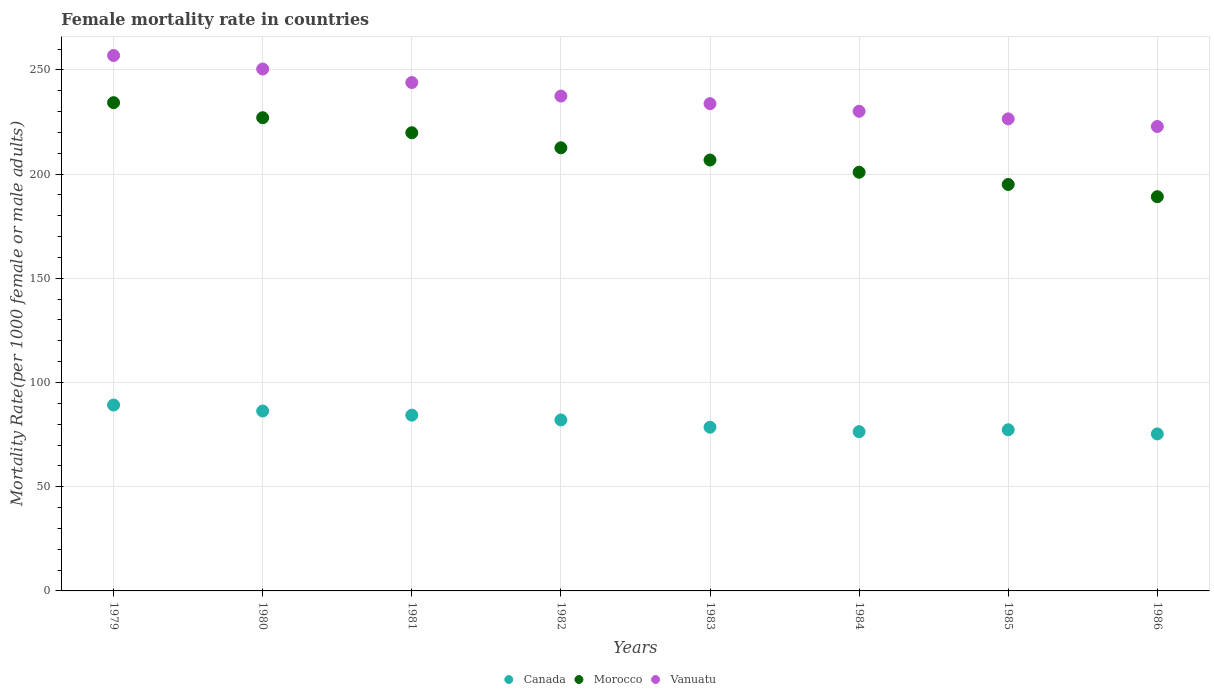How many different coloured dotlines are there?
Give a very brief answer. 3. What is the female mortality rate in Morocco in 1982?
Offer a very short reply. 212.62. Across all years, what is the maximum female mortality rate in Morocco?
Offer a terse response. 234.28. Across all years, what is the minimum female mortality rate in Canada?
Offer a terse response. 75.33. In which year was the female mortality rate in Morocco maximum?
Keep it short and to the point. 1979. In which year was the female mortality rate in Vanuatu minimum?
Make the answer very short. 1986. What is the total female mortality rate in Canada in the graph?
Ensure brevity in your answer.  649.49. What is the difference between the female mortality rate in Canada in 1981 and that in 1986?
Offer a terse response. 9. What is the difference between the female mortality rate in Vanuatu in 1981 and the female mortality rate in Morocco in 1980?
Offer a very short reply. 16.88. What is the average female mortality rate in Morocco per year?
Offer a very short reply. 210.7. In the year 1984, what is the difference between the female mortality rate in Morocco and female mortality rate in Vanuatu?
Ensure brevity in your answer.  -29.26. What is the ratio of the female mortality rate in Morocco in 1979 to that in 1982?
Make the answer very short. 1.1. Is the difference between the female mortality rate in Morocco in 1982 and 1984 greater than the difference between the female mortality rate in Vanuatu in 1982 and 1984?
Provide a succinct answer. Yes. What is the difference between the highest and the second highest female mortality rate in Vanuatu?
Offer a very short reply. 6.49. What is the difference between the highest and the lowest female mortality rate in Vanuatu?
Offer a terse response. 34.06. Is the sum of the female mortality rate in Morocco in 1982 and 1984 greater than the maximum female mortality rate in Canada across all years?
Your response must be concise. Yes. How many dotlines are there?
Your answer should be very brief. 3. How many years are there in the graph?
Your answer should be compact. 8. What is the difference between two consecutive major ticks on the Y-axis?
Your response must be concise. 50. Are the values on the major ticks of Y-axis written in scientific E-notation?
Give a very brief answer. No. Does the graph contain any zero values?
Your response must be concise. No. How are the legend labels stacked?
Your response must be concise. Horizontal. What is the title of the graph?
Ensure brevity in your answer.  Female mortality rate in countries. What is the label or title of the X-axis?
Give a very brief answer. Years. What is the label or title of the Y-axis?
Provide a succinct answer. Mortality Rate(per 1000 female or male adults). What is the Mortality Rate(per 1000 female or male adults) of Canada in 1979?
Make the answer very short. 89.19. What is the Mortality Rate(per 1000 female or male adults) in Morocco in 1979?
Make the answer very short. 234.28. What is the Mortality Rate(per 1000 female or male adults) of Vanuatu in 1979?
Your answer should be compact. 256.9. What is the Mortality Rate(per 1000 female or male adults) of Canada in 1980?
Your answer should be compact. 86.32. What is the Mortality Rate(per 1000 female or male adults) of Morocco in 1980?
Your response must be concise. 227.06. What is the Mortality Rate(per 1000 female or male adults) in Vanuatu in 1980?
Give a very brief answer. 250.42. What is the Mortality Rate(per 1000 female or male adults) in Canada in 1981?
Give a very brief answer. 84.34. What is the Mortality Rate(per 1000 female or male adults) in Morocco in 1981?
Provide a short and direct response. 219.84. What is the Mortality Rate(per 1000 female or male adults) of Vanuatu in 1981?
Make the answer very short. 243.93. What is the Mortality Rate(per 1000 female or male adults) of Canada in 1982?
Your answer should be very brief. 82.03. What is the Mortality Rate(per 1000 female or male adults) in Morocco in 1982?
Offer a very short reply. 212.62. What is the Mortality Rate(per 1000 female or male adults) of Vanuatu in 1982?
Your answer should be very brief. 237.45. What is the Mortality Rate(per 1000 female or male adults) in Canada in 1983?
Keep it short and to the point. 78.54. What is the Mortality Rate(per 1000 female or male adults) of Morocco in 1983?
Provide a short and direct response. 206.75. What is the Mortality Rate(per 1000 female or male adults) in Vanuatu in 1983?
Your answer should be very brief. 233.79. What is the Mortality Rate(per 1000 female or male adults) of Canada in 1984?
Offer a terse response. 76.41. What is the Mortality Rate(per 1000 female or male adults) of Morocco in 1984?
Your answer should be compact. 200.89. What is the Mortality Rate(per 1000 female or male adults) in Vanuatu in 1984?
Offer a terse response. 230.14. What is the Mortality Rate(per 1000 female or male adults) of Canada in 1985?
Make the answer very short. 77.33. What is the Mortality Rate(per 1000 female or male adults) of Morocco in 1985?
Your response must be concise. 195.02. What is the Mortality Rate(per 1000 female or male adults) of Vanuatu in 1985?
Provide a succinct answer. 226.49. What is the Mortality Rate(per 1000 female or male adults) in Canada in 1986?
Provide a succinct answer. 75.33. What is the Mortality Rate(per 1000 female or male adults) in Morocco in 1986?
Offer a terse response. 189.16. What is the Mortality Rate(per 1000 female or male adults) of Vanuatu in 1986?
Offer a terse response. 222.84. Across all years, what is the maximum Mortality Rate(per 1000 female or male adults) of Canada?
Provide a short and direct response. 89.19. Across all years, what is the maximum Mortality Rate(per 1000 female or male adults) in Morocco?
Your response must be concise. 234.28. Across all years, what is the maximum Mortality Rate(per 1000 female or male adults) in Vanuatu?
Your answer should be compact. 256.9. Across all years, what is the minimum Mortality Rate(per 1000 female or male adults) of Canada?
Make the answer very short. 75.33. Across all years, what is the minimum Mortality Rate(per 1000 female or male adults) in Morocco?
Provide a short and direct response. 189.16. Across all years, what is the minimum Mortality Rate(per 1000 female or male adults) in Vanuatu?
Keep it short and to the point. 222.84. What is the total Mortality Rate(per 1000 female or male adults) in Canada in the graph?
Make the answer very short. 649.49. What is the total Mortality Rate(per 1000 female or male adults) of Morocco in the graph?
Offer a very short reply. 1685.6. What is the total Mortality Rate(per 1000 female or male adults) of Vanuatu in the graph?
Your answer should be very brief. 1901.97. What is the difference between the Mortality Rate(per 1000 female or male adults) in Canada in 1979 and that in 1980?
Your answer should be very brief. 2.88. What is the difference between the Mortality Rate(per 1000 female or male adults) in Morocco in 1979 and that in 1980?
Your answer should be very brief. 7.22. What is the difference between the Mortality Rate(per 1000 female or male adults) in Vanuatu in 1979 and that in 1980?
Your response must be concise. 6.49. What is the difference between the Mortality Rate(per 1000 female or male adults) in Canada in 1979 and that in 1981?
Make the answer very short. 4.86. What is the difference between the Mortality Rate(per 1000 female or male adults) of Morocco in 1979 and that in 1981?
Your answer should be compact. 14.44. What is the difference between the Mortality Rate(per 1000 female or male adults) in Vanuatu in 1979 and that in 1981?
Ensure brevity in your answer.  12.97. What is the difference between the Mortality Rate(per 1000 female or male adults) of Canada in 1979 and that in 1982?
Offer a terse response. 7.16. What is the difference between the Mortality Rate(per 1000 female or male adults) in Morocco in 1979 and that in 1982?
Offer a terse response. 21.66. What is the difference between the Mortality Rate(per 1000 female or male adults) in Vanuatu in 1979 and that in 1982?
Provide a succinct answer. 19.46. What is the difference between the Mortality Rate(per 1000 female or male adults) in Canada in 1979 and that in 1983?
Your response must be concise. 10.65. What is the difference between the Mortality Rate(per 1000 female or male adults) of Morocco in 1979 and that in 1983?
Your answer should be very brief. 27.52. What is the difference between the Mortality Rate(per 1000 female or male adults) in Vanuatu in 1979 and that in 1983?
Ensure brevity in your answer.  23.11. What is the difference between the Mortality Rate(per 1000 female or male adults) in Canada in 1979 and that in 1984?
Your answer should be very brief. 12.78. What is the difference between the Mortality Rate(per 1000 female or male adults) in Morocco in 1979 and that in 1984?
Your response must be concise. 33.39. What is the difference between the Mortality Rate(per 1000 female or male adults) of Vanuatu in 1979 and that in 1984?
Offer a terse response. 26.76. What is the difference between the Mortality Rate(per 1000 female or male adults) in Canada in 1979 and that in 1985?
Offer a very short reply. 11.87. What is the difference between the Mortality Rate(per 1000 female or male adults) in Morocco in 1979 and that in 1985?
Provide a short and direct response. 39.26. What is the difference between the Mortality Rate(per 1000 female or male adults) of Vanuatu in 1979 and that in 1985?
Your answer should be very brief. 30.41. What is the difference between the Mortality Rate(per 1000 female or male adults) of Canada in 1979 and that in 1986?
Provide a succinct answer. 13.86. What is the difference between the Mortality Rate(per 1000 female or male adults) of Morocco in 1979 and that in 1986?
Provide a succinct answer. 45.12. What is the difference between the Mortality Rate(per 1000 female or male adults) in Vanuatu in 1979 and that in 1986?
Your response must be concise. 34.06. What is the difference between the Mortality Rate(per 1000 female or male adults) in Canada in 1980 and that in 1981?
Ensure brevity in your answer.  1.98. What is the difference between the Mortality Rate(per 1000 female or male adults) of Morocco in 1980 and that in 1981?
Provide a succinct answer. 7.22. What is the difference between the Mortality Rate(per 1000 female or male adults) in Vanuatu in 1980 and that in 1981?
Make the answer very short. 6.49. What is the difference between the Mortality Rate(per 1000 female or male adults) in Canada in 1980 and that in 1982?
Your answer should be very brief. 4.28. What is the difference between the Mortality Rate(per 1000 female or male adults) in Morocco in 1980 and that in 1982?
Offer a terse response. 14.44. What is the difference between the Mortality Rate(per 1000 female or male adults) of Vanuatu in 1980 and that in 1982?
Offer a terse response. 12.97. What is the difference between the Mortality Rate(per 1000 female or male adults) in Canada in 1980 and that in 1983?
Give a very brief answer. 7.78. What is the difference between the Mortality Rate(per 1000 female or male adults) of Morocco in 1980 and that in 1983?
Your answer should be very brief. 20.3. What is the difference between the Mortality Rate(per 1000 female or male adults) of Vanuatu in 1980 and that in 1983?
Make the answer very short. 16.62. What is the difference between the Mortality Rate(per 1000 female or male adults) in Canada in 1980 and that in 1984?
Give a very brief answer. 9.9. What is the difference between the Mortality Rate(per 1000 female or male adults) of Morocco in 1980 and that in 1984?
Ensure brevity in your answer.  26.17. What is the difference between the Mortality Rate(per 1000 female or male adults) of Vanuatu in 1980 and that in 1984?
Make the answer very short. 20.27. What is the difference between the Mortality Rate(per 1000 female or male adults) of Canada in 1980 and that in 1985?
Ensure brevity in your answer.  8.99. What is the difference between the Mortality Rate(per 1000 female or male adults) of Morocco in 1980 and that in 1985?
Your answer should be compact. 32.03. What is the difference between the Mortality Rate(per 1000 female or male adults) in Vanuatu in 1980 and that in 1985?
Keep it short and to the point. 23.93. What is the difference between the Mortality Rate(per 1000 female or male adults) of Canada in 1980 and that in 1986?
Your response must be concise. 10.98. What is the difference between the Mortality Rate(per 1000 female or male adults) of Morocco in 1980 and that in 1986?
Offer a very short reply. 37.9. What is the difference between the Mortality Rate(per 1000 female or male adults) of Vanuatu in 1980 and that in 1986?
Provide a succinct answer. 27.58. What is the difference between the Mortality Rate(per 1000 female or male adults) in Canada in 1981 and that in 1982?
Provide a succinct answer. 2.31. What is the difference between the Mortality Rate(per 1000 female or male adults) of Morocco in 1981 and that in 1982?
Make the answer very short. 7.22. What is the difference between the Mortality Rate(per 1000 female or male adults) in Vanuatu in 1981 and that in 1982?
Make the answer very short. 6.49. What is the difference between the Mortality Rate(per 1000 female or male adults) of Canada in 1981 and that in 1983?
Provide a succinct answer. 5.8. What is the difference between the Mortality Rate(per 1000 female or male adults) of Morocco in 1981 and that in 1983?
Your answer should be very brief. 13.09. What is the difference between the Mortality Rate(per 1000 female or male adults) of Vanuatu in 1981 and that in 1983?
Provide a succinct answer. 10.14. What is the difference between the Mortality Rate(per 1000 female or male adults) of Canada in 1981 and that in 1984?
Offer a very short reply. 7.93. What is the difference between the Mortality Rate(per 1000 female or male adults) of Morocco in 1981 and that in 1984?
Your response must be concise. 18.95. What is the difference between the Mortality Rate(per 1000 female or male adults) in Vanuatu in 1981 and that in 1984?
Offer a terse response. 13.79. What is the difference between the Mortality Rate(per 1000 female or male adults) of Canada in 1981 and that in 1985?
Make the answer very short. 7.01. What is the difference between the Mortality Rate(per 1000 female or male adults) in Morocco in 1981 and that in 1985?
Keep it short and to the point. 24.82. What is the difference between the Mortality Rate(per 1000 female or male adults) in Vanuatu in 1981 and that in 1985?
Offer a terse response. 17.44. What is the difference between the Mortality Rate(per 1000 female or male adults) of Canada in 1981 and that in 1986?
Keep it short and to the point. 9. What is the difference between the Mortality Rate(per 1000 female or male adults) in Morocco in 1981 and that in 1986?
Your answer should be very brief. 30.68. What is the difference between the Mortality Rate(per 1000 female or male adults) of Vanuatu in 1981 and that in 1986?
Keep it short and to the point. 21.09. What is the difference between the Mortality Rate(per 1000 female or male adults) of Canada in 1982 and that in 1983?
Provide a succinct answer. 3.49. What is the difference between the Mortality Rate(per 1000 female or male adults) in Morocco in 1982 and that in 1983?
Provide a short and direct response. 5.87. What is the difference between the Mortality Rate(per 1000 female or male adults) in Vanuatu in 1982 and that in 1983?
Offer a very short reply. 3.65. What is the difference between the Mortality Rate(per 1000 female or male adults) of Canada in 1982 and that in 1984?
Offer a very short reply. 5.62. What is the difference between the Mortality Rate(per 1000 female or male adults) in Morocco in 1982 and that in 1984?
Offer a very short reply. 11.73. What is the difference between the Mortality Rate(per 1000 female or male adults) in Vanuatu in 1982 and that in 1984?
Keep it short and to the point. 7.3. What is the difference between the Mortality Rate(per 1000 female or male adults) of Canada in 1982 and that in 1985?
Make the answer very short. 4.71. What is the difference between the Mortality Rate(per 1000 female or male adults) in Morocco in 1982 and that in 1985?
Offer a terse response. 17.6. What is the difference between the Mortality Rate(per 1000 female or male adults) of Vanuatu in 1982 and that in 1985?
Your response must be concise. 10.96. What is the difference between the Mortality Rate(per 1000 female or male adults) of Canada in 1982 and that in 1986?
Your response must be concise. 6.7. What is the difference between the Mortality Rate(per 1000 female or male adults) in Morocco in 1982 and that in 1986?
Make the answer very short. 23.46. What is the difference between the Mortality Rate(per 1000 female or male adults) of Vanuatu in 1982 and that in 1986?
Provide a succinct answer. 14.61. What is the difference between the Mortality Rate(per 1000 female or male adults) of Canada in 1983 and that in 1984?
Provide a succinct answer. 2.13. What is the difference between the Mortality Rate(per 1000 female or male adults) in Morocco in 1983 and that in 1984?
Provide a short and direct response. 5.87. What is the difference between the Mortality Rate(per 1000 female or male adults) of Vanuatu in 1983 and that in 1984?
Your answer should be very brief. 3.65. What is the difference between the Mortality Rate(per 1000 female or male adults) in Canada in 1983 and that in 1985?
Give a very brief answer. 1.21. What is the difference between the Mortality Rate(per 1000 female or male adults) in Morocco in 1983 and that in 1985?
Your answer should be very brief. 11.73. What is the difference between the Mortality Rate(per 1000 female or male adults) in Vanuatu in 1983 and that in 1985?
Your answer should be compact. 7.3. What is the difference between the Mortality Rate(per 1000 female or male adults) in Canada in 1983 and that in 1986?
Offer a very short reply. 3.21. What is the difference between the Mortality Rate(per 1000 female or male adults) of Morocco in 1983 and that in 1986?
Make the answer very short. 17.6. What is the difference between the Mortality Rate(per 1000 female or male adults) of Vanuatu in 1983 and that in 1986?
Your answer should be very brief. 10.96. What is the difference between the Mortality Rate(per 1000 female or male adults) in Canada in 1984 and that in 1985?
Make the answer very short. -0.92. What is the difference between the Mortality Rate(per 1000 female or male adults) in Morocco in 1984 and that in 1985?
Offer a terse response. 5.87. What is the difference between the Mortality Rate(per 1000 female or male adults) in Vanuatu in 1984 and that in 1985?
Your answer should be very brief. 3.65. What is the difference between the Mortality Rate(per 1000 female or male adults) of Canada in 1984 and that in 1986?
Make the answer very short. 1.08. What is the difference between the Mortality Rate(per 1000 female or male adults) of Morocco in 1984 and that in 1986?
Keep it short and to the point. 11.73. What is the difference between the Mortality Rate(per 1000 female or male adults) in Vanuatu in 1984 and that in 1986?
Keep it short and to the point. 7.3. What is the difference between the Mortality Rate(per 1000 female or male adults) of Canada in 1985 and that in 1986?
Provide a short and direct response. 1.99. What is the difference between the Mortality Rate(per 1000 female or male adults) in Morocco in 1985 and that in 1986?
Your answer should be very brief. 5.87. What is the difference between the Mortality Rate(per 1000 female or male adults) in Vanuatu in 1985 and that in 1986?
Your answer should be compact. 3.65. What is the difference between the Mortality Rate(per 1000 female or male adults) in Canada in 1979 and the Mortality Rate(per 1000 female or male adults) in Morocco in 1980?
Your response must be concise. -137.86. What is the difference between the Mortality Rate(per 1000 female or male adults) in Canada in 1979 and the Mortality Rate(per 1000 female or male adults) in Vanuatu in 1980?
Give a very brief answer. -161.22. What is the difference between the Mortality Rate(per 1000 female or male adults) in Morocco in 1979 and the Mortality Rate(per 1000 female or male adults) in Vanuatu in 1980?
Provide a succinct answer. -16.14. What is the difference between the Mortality Rate(per 1000 female or male adults) in Canada in 1979 and the Mortality Rate(per 1000 female or male adults) in Morocco in 1981?
Your response must be concise. -130.64. What is the difference between the Mortality Rate(per 1000 female or male adults) in Canada in 1979 and the Mortality Rate(per 1000 female or male adults) in Vanuatu in 1981?
Keep it short and to the point. -154.74. What is the difference between the Mortality Rate(per 1000 female or male adults) of Morocco in 1979 and the Mortality Rate(per 1000 female or male adults) of Vanuatu in 1981?
Offer a terse response. -9.66. What is the difference between the Mortality Rate(per 1000 female or male adults) in Canada in 1979 and the Mortality Rate(per 1000 female or male adults) in Morocco in 1982?
Keep it short and to the point. -123.42. What is the difference between the Mortality Rate(per 1000 female or male adults) in Canada in 1979 and the Mortality Rate(per 1000 female or male adults) in Vanuatu in 1982?
Offer a terse response. -148.25. What is the difference between the Mortality Rate(per 1000 female or male adults) of Morocco in 1979 and the Mortality Rate(per 1000 female or male adults) of Vanuatu in 1982?
Your response must be concise. -3.17. What is the difference between the Mortality Rate(per 1000 female or male adults) of Canada in 1979 and the Mortality Rate(per 1000 female or male adults) of Morocco in 1983?
Offer a very short reply. -117.56. What is the difference between the Mortality Rate(per 1000 female or male adults) of Canada in 1979 and the Mortality Rate(per 1000 female or male adults) of Vanuatu in 1983?
Make the answer very short. -144.6. What is the difference between the Mortality Rate(per 1000 female or male adults) in Morocco in 1979 and the Mortality Rate(per 1000 female or male adults) in Vanuatu in 1983?
Give a very brief answer. 0.48. What is the difference between the Mortality Rate(per 1000 female or male adults) in Canada in 1979 and the Mortality Rate(per 1000 female or male adults) in Morocco in 1984?
Make the answer very short. -111.69. What is the difference between the Mortality Rate(per 1000 female or male adults) in Canada in 1979 and the Mortality Rate(per 1000 female or male adults) in Vanuatu in 1984?
Ensure brevity in your answer.  -140.95. What is the difference between the Mortality Rate(per 1000 female or male adults) of Morocco in 1979 and the Mortality Rate(per 1000 female or male adults) of Vanuatu in 1984?
Make the answer very short. 4.13. What is the difference between the Mortality Rate(per 1000 female or male adults) in Canada in 1979 and the Mortality Rate(per 1000 female or male adults) in Morocco in 1985?
Keep it short and to the point. -105.83. What is the difference between the Mortality Rate(per 1000 female or male adults) of Canada in 1979 and the Mortality Rate(per 1000 female or male adults) of Vanuatu in 1985?
Keep it short and to the point. -137.3. What is the difference between the Mortality Rate(per 1000 female or male adults) in Morocco in 1979 and the Mortality Rate(per 1000 female or male adults) in Vanuatu in 1985?
Provide a short and direct response. 7.78. What is the difference between the Mortality Rate(per 1000 female or male adults) in Canada in 1979 and the Mortality Rate(per 1000 female or male adults) in Morocco in 1986?
Give a very brief answer. -99.96. What is the difference between the Mortality Rate(per 1000 female or male adults) of Canada in 1979 and the Mortality Rate(per 1000 female or male adults) of Vanuatu in 1986?
Ensure brevity in your answer.  -133.65. What is the difference between the Mortality Rate(per 1000 female or male adults) in Morocco in 1979 and the Mortality Rate(per 1000 female or male adults) in Vanuatu in 1986?
Make the answer very short. 11.44. What is the difference between the Mortality Rate(per 1000 female or male adults) of Canada in 1980 and the Mortality Rate(per 1000 female or male adults) of Morocco in 1981?
Your answer should be very brief. -133.52. What is the difference between the Mortality Rate(per 1000 female or male adults) in Canada in 1980 and the Mortality Rate(per 1000 female or male adults) in Vanuatu in 1981?
Your response must be concise. -157.62. What is the difference between the Mortality Rate(per 1000 female or male adults) in Morocco in 1980 and the Mortality Rate(per 1000 female or male adults) in Vanuatu in 1981?
Your answer should be very brief. -16.88. What is the difference between the Mortality Rate(per 1000 female or male adults) of Canada in 1980 and the Mortality Rate(per 1000 female or male adults) of Morocco in 1982?
Your response must be concise. -126.3. What is the difference between the Mortality Rate(per 1000 female or male adults) of Canada in 1980 and the Mortality Rate(per 1000 female or male adults) of Vanuatu in 1982?
Your answer should be very brief. -151.13. What is the difference between the Mortality Rate(per 1000 female or male adults) in Morocco in 1980 and the Mortality Rate(per 1000 female or male adults) in Vanuatu in 1982?
Offer a very short reply. -10.39. What is the difference between the Mortality Rate(per 1000 female or male adults) of Canada in 1980 and the Mortality Rate(per 1000 female or male adults) of Morocco in 1983?
Your answer should be compact. -120.44. What is the difference between the Mortality Rate(per 1000 female or male adults) in Canada in 1980 and the Mortality Rate(per 1000 female or male adults) in Vanuatu in 1983?
Make the answer very short. -147.48. What is the difference between the Mortality Rate(per 1000 female or male adults) of Morocco in 1980 and the Mortality Rate(per 1000 female or male adults) of Vanuatu in 1983?
Give a very brief answer. -6.74. What is the difference between the Mortality Rate(per 1000 female or male adults) in Canada in 1980 and the Mortality Rate(per 1000 female or male adults) in Morocco in 1984?
Your answer should be very brief. -114.57. What is the difference between the Mortality Rate(per 1000 female or male adults) of Canada in 1980 and the Mortality Rate(per 1000 female or male adults) of Vanuatu in 1984?
Offer a very short reply. -143.83. What is the difference between the Mortality Rate(per 1000 female or male adults) in Morocco in 1980 and the Mortality Rate(per 1000 female or male adults) in Vanuatu in 1984?
Make the answer very short. -3.09. What is the difference between the Mortality Rate(per 1000 female or male adults) of Canada in 1980 and the Mortality Rate(per 1000 female or male adults) of Morocco in 1985?
Your answer should be very brief. -108.7. What is the difference between the Mortality Rate(per 1000 female or male adults) in Canada in 1980 and the Mortality Rate(per 1000 female or male adults) in Vanuatu in 1985?
Provide a short and direct response. -140.18. What is the difference between the Mortality Rate(per 1000 female or male adults) in Morocco in 1980 and the Mortality Rate(per 1000 female or male adults) in Vanuatu in 1985?
Provide a short and direct response. 0.56. What is the difference between the Mortality Rate(per 1000 female or male adults) in Canada in 1980 and the Mortality Rate(per 1000 female or male adults) in Morocco in 1986?
Make the answer very short. -102.84. What is the difference between the Mortality Rate(per 1000 female or male adults) in Canada in 1980 and the Mortality Rate(per 1000 female or male adults) in Vanuatu in 1986?
Offer a very short reply. -136.52. What is the difference between the Mortality Rate(per 1000 female or male adults) in Morocco in 1980 and the Mortality Rate(per 1000 female or male adults) in Vanuatu in 1986?
Your answer should be very brief. 4.22. What is the difference between the Mortality Rate(per 1000 female or male adults) in Canada in 1981 and the Mortality Rate(per 1000 female or male adults) in Morocco in 1982?
Offer a very short reply. -128.28. What is the difference between the Mortality Rate(per 1000 female or male adults) in Canada in 1981 and the Mortality Rate(per 1000 female or male adults) in Vanuatu in 1982?
Your answer should be very brief. -153.11. What is the difference between the Mortality Rate(per 1000 female or male adults) in Morocco in 1981 and the Mortality Rate(per 1000 female or male adults) in Vanuatu in 1982?
Offer a very short reply. -17.61. What is the difference between the Mortality Rate(per 1000 female or male adults) in Canada in 1981 and the Mortality Rate(per 1000 female or male adults) in Morocco in 1983?
Your response must be concise. -122.41. What is the difference between the Mortality Rate(per 1000 female or male adults) of Canada in 1981 and the Mortality Rate(per 1000 female or male adults) of Vanuatu in 1983?
Provide a short and direct response. -149.46. What is the difference between the Mortality Rate(per 1000 female or male adults) in Morocco in 1981 and the Mortality Rate(per 1000 female or male adults) in Vanuatu in 1983?
Offer a terse response. -13.96. What is the difference between the Mortality Rate(per 1000 female or male adults) of Canada in 1981 and the Mortality Rate(per 1000 female or male adults) of Morocco in 1984?
Offer a terse response. -116.55. What is the difference between the Mortality Rate(per 1000 female or male adults) in Canada in 1981 and the Mortality Rate(per 1000 female or male adults) in Vanuatu in 1984?
Your response must be concise. -145.81. What is the difference between the Mortality Rate(per 1000 female or male adults) in Morocco in 1981 and the Mortality Rate(per 1000 female or male adults) in Vanuatu in 1984?
Your answer should be compact. -10.31. What is the difference between the Mortality Rate(per 1000 female or male adults) of Canada in 1981 and the Mortality Rate(per 1000 female or male adults) of Morocco in 1985?
Your response must be concise. -110.68. What is the difference between the Mortality Rate(per 1000 female or male adults) in Canada in 1981 and the Mortality Rate(per 1000 female or male adults) in Vanuatu in 1985?
Offer a very short reply. -142.15. What is the difference between the Mortality Rate(per 1000 female or male adults) of Morocco in 1981 and the Mortality Rate(per 1000 female or male adults) of Vanuatu in 1985?
Provide a succinct answer. -6.66. What is the difference between the Mortality Rate(per 1000 female or male adults) of Canada in 1981 and the Mortality Rate(per 1000 female or male adults) of Morocco in 1986?
Keep it short and to the point. -104.82. What is the difference between the Mortality Rate(per 1000 female or male adults) of Canada in 1981 and the Mortality Rate(per 1000 female or male adults) of Vanuatu in 1986?
Your response must be concise. -138.5. What is the difference between the Mortality Rate(per 1000 female or male adults) of Morocco in 1981 and the Mortality Rate(per 1000 female or male adults) of Vanuatu in 1986?
Offer a terse response. -3. What is the difference between the Mortality Rate(per 1000 female or male adults) in Canada in 1982 and the Mortality Rate(per 1000 female or male adults) in Morocco in 1983?
Provide a succinct answer. -124.72. What is the difference between the Mortality Rate(per 1000 female or male adults) in Canada in 1982 and the Mortality Rate(per 1000 female or male adults) in Vanuatu in 1983?
Ensure brevity in your answer.  -151.76. What is the difference between the Mortality Rate(per 1000 female or male adults) of Morocco in 1982 and the Mortality Rate(per 1000 female or male adults) of Vanuatu in 1983?
Your answer should be very brief. -21.18. What is the difference between the Mortality Rate(per 1000 female or male adults) of Canada in 1982 and the Mortality Rate(per 1000 female or male adults) of Morocco in 1984?
Offer a terse response. -118.85. What is the difference between the Mortality Rate(per 1000 female or male adults) in Canada in 1982 and the Mortality Rate(per 1000 female or male adults) in Vanuatu in 1984?
Offer a very short reply. -148.11. What is the difference between the Mortality Rate(per 1000 female or male adults) of Morocco in 1982 and the Mortality Rate(per 1000 female or male adults) of Vanuatu in 1984?
Offer a terse response. -17.53. What is the difference between the Mortality Rate(per 1000 female or male adults) in Canada in 1982 and the Mortality Rate(per 1000 female or male adults) in Morocco in 1985?
Provide a short and direct response. -112.99. What is the difference between the Mortality Rate(per 1000 female or male adults) of Canada in 1982 and the Mortality Rate(per 1000 female or male adults) of Vanuatu in 1985?
Make the answer very short. -144.46. What is the difference between the Mortality Rate(per 1000 female or male adults) in Morocco in 1982 and the Mortality Rate(per 1000 female or male adults) in Vanuatu in 1985?
Offer a very short reply. -13.88. What is the difference between the Mortality Rate(per 1000 female or male adults) in Canada in 1982 and the Mortality Rate(per 1000 female or male adults) in Morocco in 1986?
Provide a short and direct response. -107.12. What is the difference between the Mortality Rate(per 1000 female or male adults) in Canada in 1982 and the Mortality Rate(per 1000 female or male adults) in Vanuatu in 1986?
Give a very brief answer. -140.81. What is the difference between the Mortality Rate(per 1000 female or male adults) in Morocco in 1982 and the Mortality Rate(per 1000 female or male adults) in Vanuatu in 1986?
Your response must be concise. -10.22. What is the difference between the Mortality Rate(per 1000 female or male adults) in Canada in 1983 and the Mortality Rate(per 1000 female or male adults) in Morocco in 1984?
Keep it short and to the point. -122.35. What is the difference between the Mortality Rate(per 1000 female or male adults) of Canada in 1983 and the Mortality Rate(per 1000 female or male adults) of Vanuatu in 1984?
Offer a very short reply. -151.6. What is the difference between the Mortality Rate(per 1000 female or male adults) in Morocco in 1983 and the Mortality Rate(per 1000 female or male adults) in Vanuatu in 1984?
Your response must be concise. -23.39. What is the difference between the Mortality Rate(per 1000 female or male adults) of Canada in 1983 and the Mortality Rate(per 1000 female or male adults) of Morocco in 1985?
Your answer should be very brief. -116.48. What is the difference between the Mortality Rate(per 1000 female or male adults) in Canada in 1983 and the Mortality Rate(per 1000 female or male adults) in Vanuatu in 1985?
Ensure brevity in your answer.  -147.95. What is the difference between the Mortality Rate(per 1000 female or male adults) in Morocco in 1983 and the Mortality Rate(per 1000 female or male adults) in Vanuatu in 1985?
Your answer should be compact. -19.74. What is the difference between the Mortality Rate(per 1000 female or male adults) in Canada in 1983 and the Mortality Rate(per 1000 female or male adults) in Morocco in 1986?
Make the answer very short. -110.61. What is the difference between the Mortality Rate(per 1000 female or male adults) in Canada in 1983 and the Mortality Rate(per 1000 female or male adults) in Vanuatu in 1986?
Make the answer very short. -144.3. What is the difference between the Mortality Rate(per 1000 female or male adults) of Morocco in 1983 and the Mortality Rate(per 1000 female or male adults) of Vanuatu in 1986?
Your answer should be compact. -16.09. What is the difference between the Mortality Rate(per 1000 female or male adults) of Canada in 1984 and the Mortality Rate(per 1000 female or male adults) of Morocco in 1985?
Your answer should be very brief. -118.61. What is the difference between the Mortality Rate(per 1000 female or male adults) in Canada in 1984 and the Mortality Rate(per 1000 female or male adults) in Vanuatu in 1985?
Provide a short and direct response. -150.08. What is the difference between the Mortality Rate(per 1000 female or male adults) in Morocco in 1984 and the Mortality Rate(per 1000 female or male adults) in Vanuatu in 1985?
Ensure brevity in your answer.  -25.61. What is the difference between the Mortality Rate(per 1000 female or male adults) of Canada in 1984 and the Mortality Rate(per 1000 female or male adults) of Morocco in 1986?
Your response must be concise. -112.74. What is the difference between the Mortality Rate(per 1000 female or male adults) in Canada in 1984 and the Mortality Rate(per 1000 female or male adults) in Vanuatu in 1986?
Your answer should be compact. -146.43. What is the difference between the Mortality Rate(per 1000 female or male adults) in Morocco in 1984 and the Mortality Rate(per 1000 female or male adults) in Vanuatu in 1986?
Provide a succinct answer. -21.95. What is the difference between the Mortality Rate(per 1000 female or male adults) of Canada in 1985 and the Mortality Rate(per 1000 female or male adults) of Morocco in 1986?
Your answer should be compact. -111.83. What is the difference between the Mortality Rate(per 1000 female or male adults) of Canada in 1985 and the Mortality Rate(per 1000 female or male adults) of Vanuatu in 1986?
Make the answer very short. -145.51. What is the difference between the Mortality Rate(per 1000 female or male adults) of Morocco in 1985 and the Mortality Rate(per 1000 female or male adults) of Vanuatu in 1986?
Make the answer very short. -27.82. What is the average Mortality Rate(per 1000 female or male adults) of Canada per year?
Give a very brief answer. 81.19. What is the average Mortality Rate(per 1000 female or male adults) of Morocco per year?
Provide a short and direct response. 210.7. What is the average Mortality Rate(per 1000 female or male adults) of Vanuatu per year?
Your answer should be very brief. 237.75. In the year 1979, what is the difference between the Mortality Rate(per 1000 female or male adults) in Canada and Mortality Rate(per 1000 female or male adults) in Morocco?
Offer a terse response. -145.08. In the year 1979, what is the difference between the Mortality Rate(per 1000 female or male adults) of Canada and Mortality Rate(per 1000 female or male adults) of Vanuatu?
Your answer should be very brief. -167.71. In the year 1979, what is the difference between the Mortality Rate(per 1000 female or male adults) of Morocco and Mortality Rate(per 1000 female or male adults) of Vanuatu?
Your answer should be very brief. -22.63. In the year 1980, what is the difference between the Mortality Rate(per 1000 female or male adults) in Canada and Mortality Rate(per 1000 female or male adults) in Morocco?
Your answer should be very brief. -140.74. In the year 1980, what is the difference between the Mortality Rate(per 1000 female or male adults) of Canada and Mortality Rate(per 1000 female or male adults) of Vanuatu?
Your answer should be compact. -164.1. In the year 1980, what is the difference between the Mortality Rate(per 1000 female or male adults) in Morocco and Mortality Rate(per 1000 female or male adults) in Vanuatu?
Offer a terse response. -23.36. In the year 1981, what is the difference between the Mortality Rate(per 1000 female or male adults) of Canada and Mortality Rate(per 1000 female or male adults) of Morocco?
Give a very brief answer. -135.5. In the year 1981, what is the difference between the Mortality Rate(per 1000 female or male adults) in Canada and Mortality Rate(per 1000 female or male adults) in Vanuatu?
Ensure brevity in your answer.  -159.59. In the year 1981, what is the difference between the Mortality Rate(per 1000 female or male adults) in Morocco and Mortality Rate(per 1000 female or male adults) in Vanuatu?
Your answer should be very brief. -24.1. In the year 1982, what is the difference between the Mortality Rate(per 1000 female or male adults) of Canada and Mortality Rate(per 1000 female or male adults) of Morocco?
Your answer should be compact. -130.58. In the year 1982, what is the difference between the Mortality Rate(per 1000 female or male adults) in Canada and Mortality Rate(per 1000 female or male adults) in Vanuatu?
Give a very brief answer. -155.41. In the year 1982, what is the difference between the Mortality Rate(per 1000 female or male adults) in Morocco and Mortality Rate(per 1000 female or male adults) in Vanuatu?
Your answer should be very brief. -24.83. In the year 1983, what is the difference between the Mortality Rate(per 1000 female or male adults) of Canada and Mortality Rate(per 1000 female or male adults) of Morocco?
Keep it short and to the point. -128.21. In the year 1983, what is the difference between the Mortality Rate(per 1000 female or male adults) of Canada and Mortality Rate(per 1000 female or male adults) of Vanuatu?
Your answer should be very brief. -155.25. In the year 1983, what is the difference between the Mortality Rate(per 1000 female or male adults) in Morocco and Mortality Rate(per 1000 female or male adults) in Vanuatu?
Offer a very short reply. -27.04. In the year 1984, what is the difference between the Mortality Rate(per 1000 female or male adults) in Canada and Mortality Rate(per 1000 female or male adults) in Morocco?
Keep it short and to the point. -124.47. In the year 1984, what is the difference between the Mortality Rate(per 1000 female or male adults) in Canada and Mortality Rate(per 1000 female or male adults) in Vanuatu?
Ensure brevity in your answer.  -153.73. In the year 1984, what is the difference between the Mortality Rate(per 1000 female or male adults) of Morocco and Mortality Rate(per 1000 female or male adults) of Vanuatu?
Your answer should be compact. -29.26. In the year 1985, what is the difference between the Mortality Rate(per 1000 female or male adults) of Canada and Mortality Rate(per 1000 female or male adults) of Morocco?
Offer a very short reply. -117.69. In the year 1985, what is the difference between the Mortality Rate(per 1000 female or male adults) in Canada and Mortality Rate(per 1000 female or male adults) in Vanuatu?
Your answer should be compact. -149.17. In the year 1985, what is the difference between the Mortality Rate(per 1000 female or male adults) in Morocco and Mortality Rate(per 1000 female or male adults) in Vanuatu?
Give a very brief answer. -31.47. In the year 1986, what is the difference between the Mortality Rate(per 1000 female or male adults) of Canada and Mortality Rate(per 1000 female or male adults) of Morocco?
Make the answer very short. -113.82. In the year 1986, what is the difference between the Mortality Rate(per 1000 female or male adults) of Canada and Mortality Rate(per 1000 female or male adults) of Vanuatu?
Provide a short and direct response. -147.51. In the year 1986, what is the difference between the Mortality Rate(per 1000 female or male adults) in Morocco and Mortality Rate(per 1000 female or male adults) in Vanuatu?
Offer a terse response. -33.69. What is the ratio of the Mortality Rate(per 1000 female or male adults) of Canada in 1979 to that in 1980?
Your response must be concise. 1.03. What is the ratio of the Mortality Rate(per 1000 female or male adults) in Morocco in 1979 to that in 1980?
Offer a terse response. 1.03. What is the ratio of the Mortality Rate(per 1000 female or male adults) of Vanuatu in 1979 to that in 1980?
Your answer should be compact. 1.03. What is the ratio of the Mortality Rate(per 1000 female or male adults) of Canada in 1979 to that in 1981?
Keep it short and to the point. 1.06. What is the ratio of the Mortality Rate(per 1000 female or male adults) in Morocco in 1979 to that in 1981?
Your answer should be very brief. 1.07. What is the ratio of the Mortality Rate(per 1000 female or male adults) of Vanuatu in 1979 to that in 1981?
Offer a terse response. 1.05. What is the ratio of the Mortality Rate(per 1000 female or male adults) of Canada in 1979 to that in 1982?
Provide a short and direct response. 1.09. What is the ratio of the Mortality Rate(per 1000 female or male adults) of Morocco in 1979 to that in 1982?
Make the answer very short. 1.1. What is the ratio of the Mortality Rate(per 1000 female or male adults) of Vanuatu in 1979 to that in 1982?
Give a very brief answer. 1.08. What is the ratio of the Mortality Rate(per 1000 female or male adults) in Canada in 1979 to that in 1983?
Give a very brief answer. 1.14. What is the ratio of the Mortality Rate(per 1000 female or male adults) in Morocco in 1979 to that in 1983?
Provide a succinct answer. 1.13. What is the ratio of the Mortality Rate(per 1000 female or male adults) in Vanuatu in 1979 to that in 1983?
Your answer should be very brief. 1.1. What is the ratio of the Mortality Rate(per 1000 female or male adults) of Canada in 1979 to that in 1984?
Ensure brevity in your answer.  1.17. What is the ratio of the Mortality Rate(per 1000 female or male adults) in Morocco in 1979 to that in 1984?
Your response must be concise. 1.17. What is the ratio of the Mortality Rate(per 1000 female or male adults) in Vanuatu in 1979 to that in 1984?
Your response must be concise. 1.12. What is the ratio of the Mortality Rate(per 1000 female or male adults) in Canada in 1979 to that in 1985?
Your response must be concise. 1.15. What is the ratio of the Mortality Rate(per 1000 female or male adults) in Morocco in 1979 to that in 1985?
Your response must be concise. 1.2. What is the ratio of the Mortality Rate(per 1000 female or male adults) in Vanuatu in 1979 to that in 1985?
Offer a terse response. 1.13. What is the ratio of the Mortality Rate(per 1000 female or male adults) of Canada in 1979 to that in 1986?
Offer a terse response. 1.18. What is the ratio of the Mortality Rate(per 1000 female or male adults) of Morocco in 1979 to that in 1986?
Your answer should be very brief. 1.24. What is the ratio of the Mortality Rate(per 1000 female or male adults) of Vanuatu in 1979 to that in 1986?
Make the answer very short. 1.15. What is the ratio of the Mortality Rate(per 1000 female or male adults) in Canada in 1980 to that in 1981?
Make the answer very short. 1.02. What is the ratio of the Mortality Rate(per 1000 female or male adults) in Morocco in 1980 to that in 1981?
Your response must be concise. 1.03. What is the ratio of the Mortality Rate(per 1000 female or male adults) of Vanuatu in 1980 to that in 1981?
Offer a terse response. 1.03. What is the ratio of the Mortality Rate(per 1000 female or male adults) of Canada in 1980 to that in 1982?
Provide a short and direct response. 1.05. What is the ratio of the Mortality Rate(per 1000 female or male adults) of Morocco in 1980 to that in 1982?
Your response must be concise. 1.07. What is the ratio of the Mortality Rate(per 1000 female or male adults) of Vanuatu in 1980 to that in 1982?
Your answer should be very brief. 1.05. What is the ratio of the Mortality Rate(per 1000 female or male adults) in Canada in 1980 to that in 1983?
Provide a short and direct response. 1.1. What is the ratio of the Mortality Rate(per 1000 female or male adults) of Morocco in 1980 to that in 1983?
Your answer should be very brief. 1.1. What is the ratio of the Mortality Rate(per 1000 female or male adults) of Vanuatu in 1980 to that in 1983?
Your response must be concise. 1.07. What is the ratio of the Mortality Rate(per 1000 female or male adults) in Canada in 1980 to that in 1984?
Make the answer very short. 1.13. What is the ratio of the Mortality Rate(per 1000 female or male adults) of Morocco in 1980 to that in 1984?
Ensure brevity in your answer.  1.13. What is the ratio of the Mortality Rate(per 1000 female or male adults) in Vanuatu in 1980 to that in 1984?
Offer a very short reply. 1.09. What is the ratio of the Mortality Rate(per 1000 female or male adults) of Canada in 1980 to that in 1985?
Your answer should be very brief. 1.12. What is the ratio of the Mortality Rate(per 1000 female or male adults) in Morocco in 1980 to that in 1985?
Your answer should be very brief. 1.16. What is the ratio of the Mortality Rate(per 1000 female or male adults) in Vanuatu in 1980 to that in 1985?
Provide a short and direct response. 1.11. What is the ratio of the Mortality Rate(per 1000 female or male adults) of Canada in 1980 to that in 1986?
Ensure brevity in your answer.  1.15. What is the ratio of the Mortality Rate(per 1000 female or male adults) of Morocco in 1980 to that in 1986?
Give a very brief answer. 1.2. What is the ratio of the Mortality Rate(per 1000 female or male adults) in Vanuatu in 1980 to that in 1986?
Ensure brevity in your answer.  1.12. What is the ratio of the Mortality Rate(per 1000 female or male adults) in Canada in 1981 to that in 1982?
Ensure brevity in your answer.  1.03. What is the ratio of the Mortality Rate(per 1000 female or male adults) of Morocco in 1981 to that in 1982?
Keep it short and to the point. 1.03. What is the ratio of the Mortality Rate(per 1000 female or male adults) in Vanuatu in 1981 to that in 1982?
Offer a very short reply. 1.03. What is the ratio of the Mortality Rate(per 1000 female or male adults) in Canada in 1981 to that in 1983?
Ensure brevity in your answer.  1.07. What is the ratio of the Mortality Rate(per 1000 female or male adults) in Morocco in 1981 to that in 1983?
Offer a terse response. 1.06. What is the ratio of the Mortality Rate(per 1000 female or male adults) in Vanuatu in 1981 to that in 1983?
Offer a terse response. 1.04. What is the ratio of the Mortality Rate(per 1000 female or male adults) of Canada in 1981 to that in 1984?
Keep it short and to the point. 1.1. What is the ratio of the Mortality Rate(per 1000 female or male adults) of Morocco in 1981 to that in 1984?
Your answer should be compact. 1.09. What is the ratio of the Mortality Rate(per 1000 female or male adults) of Vanuatu in 1981 to that in 1984?
Your answer should be very brief. 1.06. What is the ratio of the Mortality Rate(per 1000 female or male adults) in Canada in 1981 to that in 1985?
Your answer should be compact. 1.09. What is the ratio of the Mortality Rate(per 1000 female or male adults) in Morocco in 1981 to that in 1985?
Make the answer very short. 1.13. What is the ratio of the Mortality Rate(per 1000 female or male adults) in Vanuatu in 1981 to that in 1985?
Ensure brevity in your answer.  1.08. What is the ratio of the Mortality Rate(per 1000 female or male adults) in Canada in 1981 to that in 1986?
Offer a very short reply. 1.12. What is the ratio of the Mortality Rate(per 1000 female or male adults) in Morocco in 1981 to that in 1986?
Provide a succinct answer. 1.16. What is the ratio of the Mortality Rate(per 1000 female or male adults) of Vanuatu in 1981 to that in 1986?
Provide a succinct answer. 1.09. What is the ratio of the Mortality Rate(per 1000 female or male adults) of Canada in 1982 to that in 1983?
Provide a short and direct response. 1.04. What is the ratio of the Mortality Rate(per 1000 female or male adults) in Morocco in 1982 to that in 1983?
Your response must be concise. 1.03. What is the ratio of the Mortality Rate(per 1000 female or male adults) of Vanuatu in 1982 to that in 1983?
Make the answer very short. 1.02. What is the ratio of the Mortality Rate(per 1000 female or male adults) of Canada in 1982 to that in 1984?
Ensure brevity in your answer.  1.07. What is the ratio of the Mortality Rate(per 1000 female or male adults) in Morocco in 1982 to that in 1984?
Provide a succinct answer. 1.06. What is the ratio of the Mortality Rate(per 1000 female or male adults) of Vanuatu in 1982 to that in 1984?
Ensure brevity in your answer.  1.03. What is the ratio of the Mortality Rate(per 1000 female or male adults) of Canada in 1982 to that in 1985?
Keep it short and to the point. 1.06. What is the ratio of the Mortality Rate(per 1000 female or male adults) of Morocco in 1982 to that in 1985?
Offer a terse response. 1.09. What is the ratio of the Mortality Rate(per 1000 female or male adults) in Vanuatu in 1982 to that in 1985?
Your answer should be very brief. 1.05. What is the ratio of the Mortality Rate(per 1000 female or male adults) of Canada in 1982 to that in 1986?
Keep it short and to the point. 1.09. What is the ratio of the Mortality Rate(per 1000 female or male adults) in Morocco in 1982 to that in 1986?
Your answer should be very brief. 1.12. What is the ratio of the Mortality Rate(per 1000 female or male adults) of Vanuatu in 1982 to that in 1986?
Make the answer very short. 1.07. What is the ratio of the Mortality Rate(per 1000 female or male adults) of Canada in 1983 to that in 1984?
Your answer should be compact. 1.03. What is the ratio of the Mortality Rate(per 1000 female or male adults) of Morocco in 1983 to that in 1984?
Give a very brief answer. 1.03. What is the ratio of the Mortality Rate(per 1000 female or male adults) of Vanuatu in 1983 to that in 1984?
Your answer should be very brief. 1.02. What is the ratio of the Mortality Rate(per 1000 female or male adults) of Canada in 1983 to that in 1985?
Give a very brief answer. 1.02. What is the ratio of the Mortality Rate(per 1000 female or male adults) in Morocco in 1983 to that in 1985?
Your answer should be very brief. 1.06. What is the ratio of the Mortality Rate(per 1000 female or male adults) of Vanuatu in 1983 to that in 1985?
Your answer should be compact. 1.03. What is the ratio of the Mortality Rate(per 1000 female or male adults) in Canada in 1983 to that in 1986?
Ensure brevity in your answer.  1.04. What is the ratio of the Mortality Rate(per 1000 female or male adults) of Morocco in 1983 to that in 1986?
Make the answer very short. 1.09. What is the ratio of the Mortality Rate(per 1000 female or male adults) of Vanuatu in 1983 to that in 1986?
Your answer should be very brief. 1.05. What is the ratio of the Mortality Rate(per 1000 female or male adults) in Morocco in 1984 to that in 1985?
Make the answer very short. 1.03. What is the ratio of the Mortality Rate(per 1000 female or male adults) of Vanuatu in 1984 to that in 1985?
Give a very brief answer. 1.02. What is the ratio of the Mortality Rate(per 1000 female or male adults) of Canada in 1984 to that in 1986?
Your response must be concise. 1.01. What is the ratio of the Mortality Rate(per 1000 female or male adults) in Morocco in 1984 to that in 1986?
Provide a short and direct response. 1.06. What is the ratio of the Mortality Rate(per 1000 female or male adults) of Vanuatu in 1984 to that in 1986?
Offer a very short reply. 1.03. What is the ratio of the Mortality Rate(per 1000 female or male adults) of Canada in 1985 to that in 1986?
Offer a very short reply. 1.03. What is the ratio of the Mortality Rate(per 1000 female or male adults) in Morocco in 1985 to that in 1986?
Your answer should be compact. 1.03. What is the ratio of the Mortality Rate(per 1000 female or male adults) in Vanuatu in 1985 to that in 1986?
Provide a succinct answer. 1.02. What is the difference between the highest and the second highest Mortality Rate(per 1000 female or male adults) of Canada?
Offer a terse response. 2.88. What is the difference between the highest and the second highest Mortality Rate(per 1000 female or male adults) in Morocco?
Your response must be concise. 7.22. What is the difference between the highest and the second highest Mortality Rate(per 1000 female or male adults) in Vanuatu?
Your response must be concise. 6.49. What is the difference between the highest and the lowest Mortality Rate(per 1000 female or male adults) of Canada?
Make the answer very short. 13.86. What is the difference between the highest and the lowest Mortality Rate(per 1000 female or male adults) in Morocco?
Keep it short and to the point. 45.12. What is the difference between the highest and the lowest Mortality Rate(per 1000 female or male adults) of Vanuatu?
Provide a short and direct response. 34.06. 